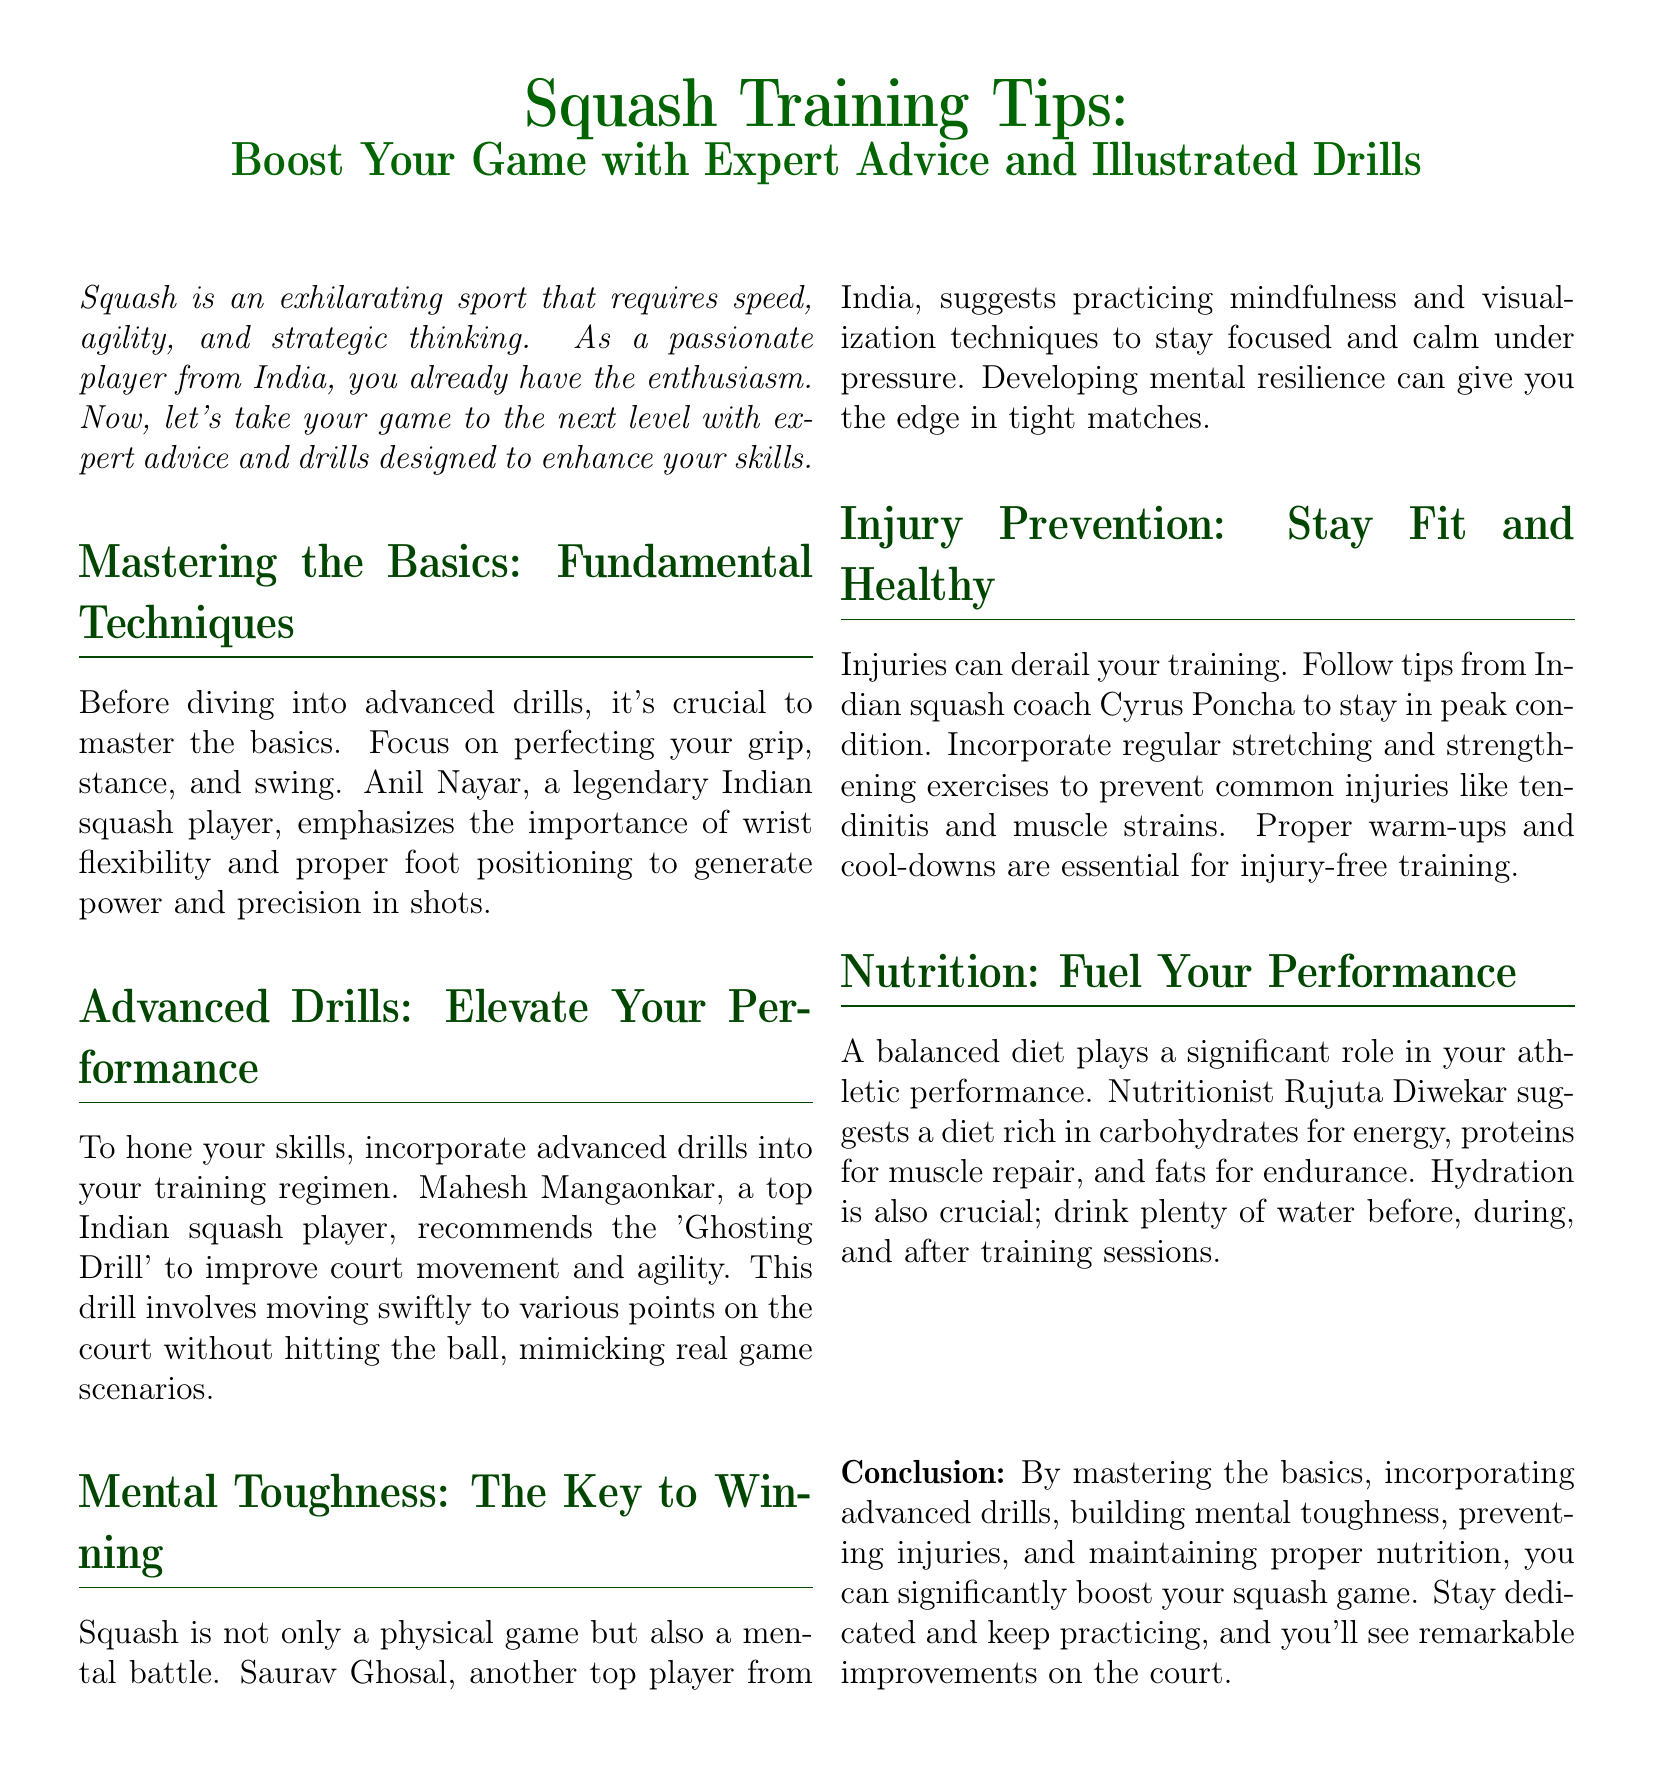What is the title of the document? The title is prominently displayed at the top of the document, outlining the main theme.
Answer: Squash Training Tips: Boost Your Game with Expert Advice and Illustrated Drills Who emphasizes wrist flexibility and proper foot positioning? This information is found in the section about mastering the basics, highlighting an influential player from India.
Answer: Anil Nayar What advanced drill is recommended for improving court movement? The document mentions a specific drill that players can incorporate to elevate their performance.
Answer: Ghosting Drill Which player suggests practicing mindfulness? This detail is included in the mental toughness section, indicating a prominent figure in Indian squash.
Answer: Saurav Ghosal What is crucial for injury prevention? The document lists important practices to maintain fitness and avoid injuries during training.
Answer: Regular stretching and strengthening exercises What type of diet is suggested for athletes? Nutrition advice presented in the document emphasizes the importance of various dietary components.
Answer: A balanced diet rich in carbohydrates, proteins, and fats How should athletes stay hydrated? The document includes specific hydration practices vital during training sessions.
Answer: Drink plenty of water before, during, and after training sessions What is the overall conclusion of the document? The conclusion summarizes key aspects of improving squash performance outlined in the document.
Answer: Mastering the basics, incorporating advanced drills, building mental toughness, preventing injuries, and maintaining proper nutrition 